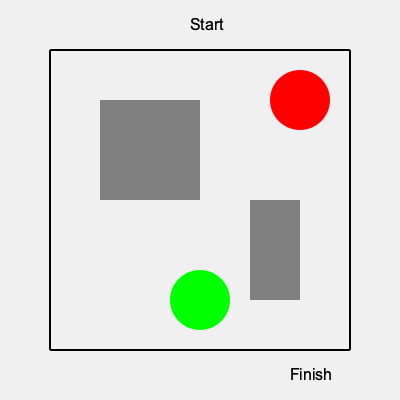As a fitness trainer organizing a community running event, you need to plan the most efficient route from the Start point (top center) to the Finish point (bottom right) in the given neighborhood map. The gray areas represent buildings, the green circle is a park, and the red circle is a construction zone. What is the minimum number of 90-degree turns required to complete this route while avoiding all obstacles? To find the most efficient route with the minimum number of 90-degree turns, we'll follow these steps:

1. Start at the top center of the map.
2. Move right until we reach the edge of the map. This requires no turns.
3. Turn 90 degrees downward to avoid the construction zone (red circle). This is the first turn.
4. Move down until we reach the top of the building on the right side. This requires no additional turns.
5. Turn 90 degrees left to go around the building. This is the second turn.
6. Move left until we clear the building. No additional turns needed.
7. Turn 90 degrees downward to continue towards the finish. This is the third turn.
8. Move down, passing between the park (green circle) and the right edge of the map, until we reach the finish point.

The route described above requires a total of 3 90-degree turns while avoiding all obstacles and reaching the finish point efficiently.
Answer: 3 turns 